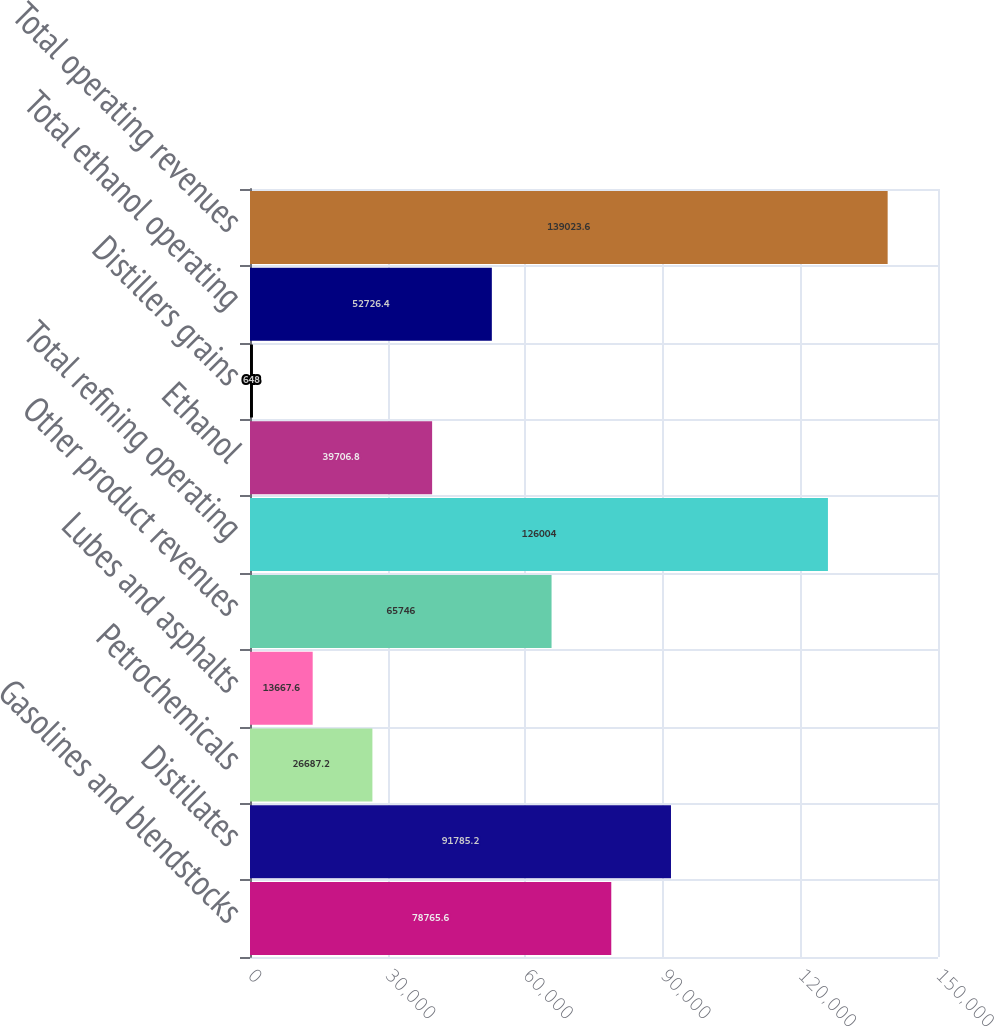Convert chart. <chart><loc_0><loc_0><loc_500><loc_500><bar_chart><fcel>Gasolines and blendstocks<fcel>Distillates<fcel>Petrochemicals<fcel>Lubes and asphalts<fcel>Other product revenues<fcel>Total refining operating<fcel>Ethanol<fcel>Distillers grains<fcel>Total ethanol operating<fcel>Total operating revenues<nl><fcel>78765.6<fcel>91785.2<fcel>26687.2<fcel>13667.6<fcel>65746<fcel>126004<fcel>39706.8<fcel>648<fcel>52726.4<fcel>139024<nl></chart> 